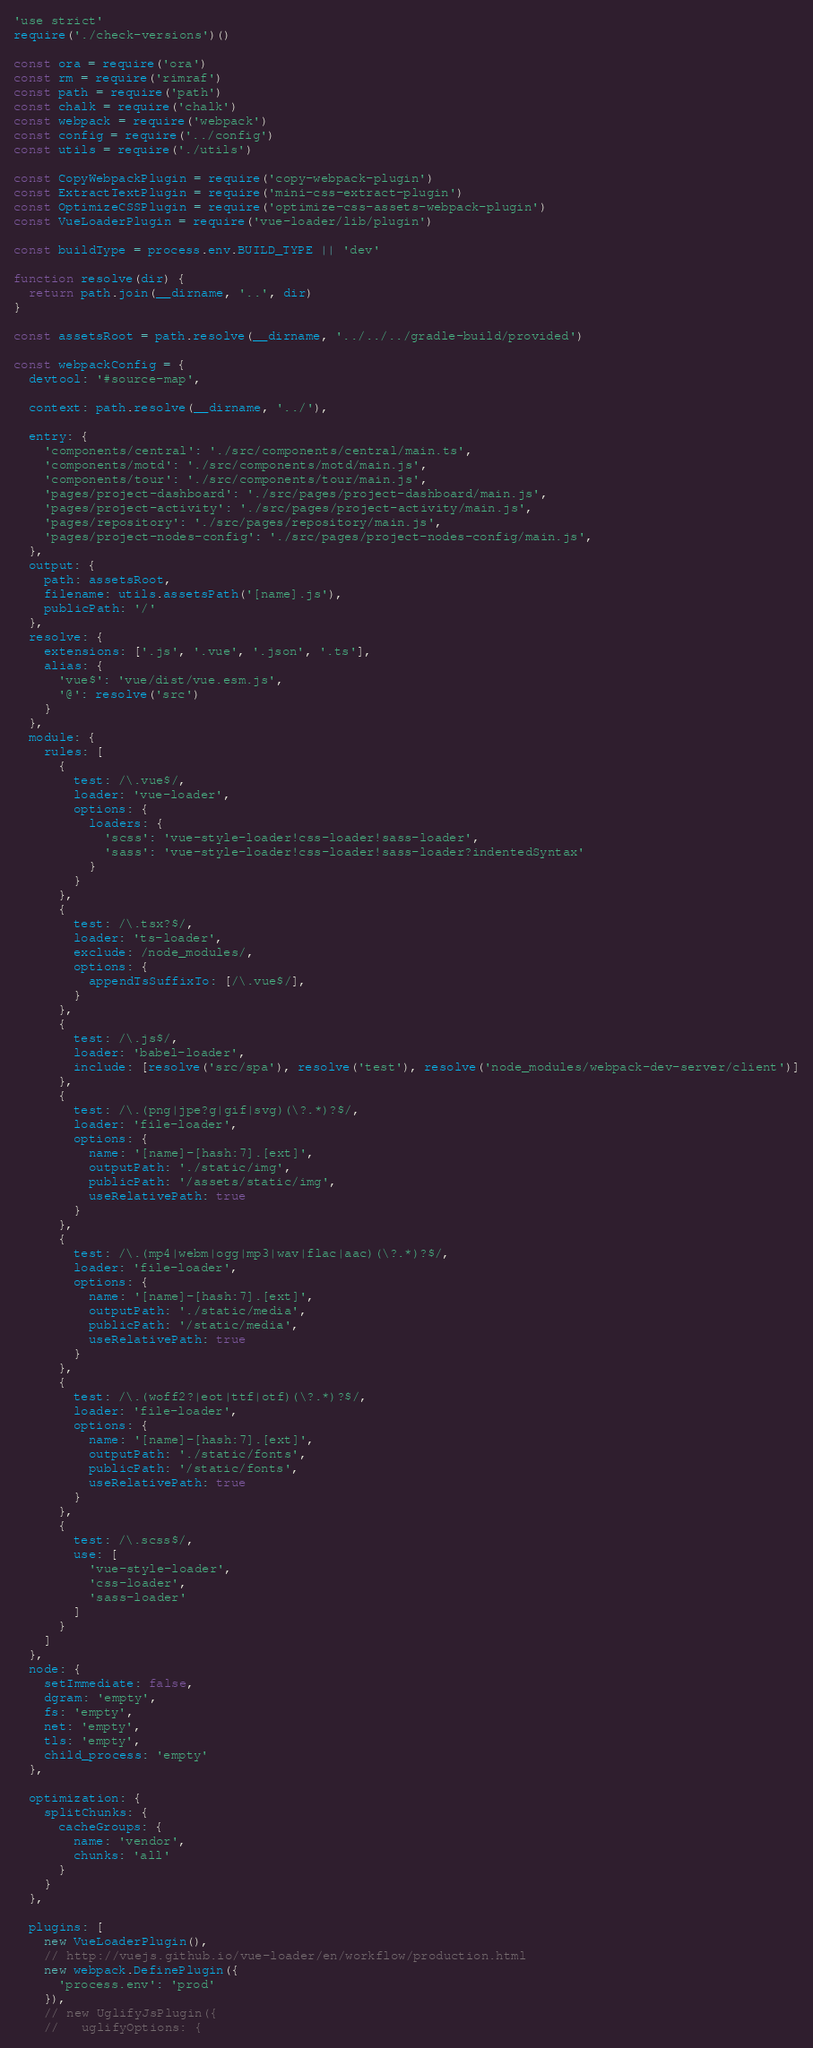<code> <loc_0><loc_0><loc_500><loc_500><_JavaScript_>'use strict'
require('./check-versions')()

const ora = require('ora')
const rm = require('rimraf')
const path = require('path')
const chalk = require('chalk')
const webpack = require('webpack')
const config = require('../config')
const utils = require('./utils')

const CopyWebpackPlugin = require('copy-webpack-plugin')
const ExtractTextPlugin = require('mini-css-extract-plugin')
const OptimizeCSSPlugin = require('optimize-css-assets-webpack-plugin')
const VueLoaderPlugin = require('vue-loader/lib/plugin')

const buildType = process.env.BUILD_TYPE || 'dev'

function resolve(dir) {
  return path.join(__dirname, '..', dir)
}

const assetsRoot = path.resolve(__dirname, '../../../gradle-build/provided')

const webpackConfig = {
  devtool: '#source-map',

  context: path.resolve(__dirname, '../'),

  entry: {
    'components/central': './src/components/central/main.ts',
    'components/motd': './src/components/motd/main.js',
    'components/tour': './src/components/tour/main.js',
    'pages/project-dashboard': './src/pages/project-dashboard/main.js',
    'pages/project-activity': './src/pages/project-activity/main.js',
    'pages/repository': './src/pages/repository/main.js',
    'pages/project-nodes-config': './src/pages/project-nodes-config/main.js',
  },
  output: {
    path: assetsRoot,
    filename: utils.assetsPath('[name].js'),
    publicPath: '/'
  },
  resolve: {
    extensions: ['.js', '.vue', '.json', '.ts'],
    alias: {
      'vue$': 'vue/dist/vue.esm.js',
      '@': resolve('src')
    }
  },
  module: {
    rules: [
      {
        test: /\.vue$/,
        loader: 'vue-loader',
        options: {
          loaders: {
            'scss': 'vue-style-loader!css-loader!sass-loader',
            'sass': 'vue-style-loader!css-loader!sass-loader?indentedSyntax'
          }
        }
      },
      {
        test: /\.tsx?$/,
        loader: 'ts-loader',
        exclude: /node_modules/,
        options: {
          appendTsSuffixTo: [/\.vue$/],
        }
      },
      {
        test: /\.js$/,
        loader: 'babel-loader',
        include: [resolve('src/spa'), resolve('test'), resolve('node_modules/webpack-dev-server/client')]
      },
      {
        test: /\.(png|jpe?g|gif|svg)(\?.*)?$/,
        loader: 'file-loader',
        options: {
          name: '[name]-[hash:7].[ext]',
          outputPath: './static/img',
          publicPath: '/assets/static/img',
          useRelativePath: true
        }
      },
      {
        test: /\.(mp4|webm|ogg|mp3|wav|flac|aac)(\?.*)?$/,
        loader: 'file-loader',
        options: {
          name: '[name]-[hash:7].[ext]',
          outputPath: './static/media',
          publicPath: '/static/media',
          useRelativePath: true
        }
      },
      {
        test: /\.(woff2?|eot|ttf|otf)(\?.*)?$/,
        loader: 'file-loader',
        options: {
          name: '[name]-[hash:7].[ext]',
          outputPath: './static/fonts',
          publicPath: '/static/fonts',
          useRelativePath: true
        }
      },
      {
        test: /\.scss$/,
        use: [
          'vue-style-loader',
          'css-loader',
          'sass-loader'
        ]
      }
    ]
  },
  node: {
    setImmediate: false,
    dgram: 'empty',
    fs: 'empty',
    net: 'empty',
    tls: 'empty',
    child_process: 'empty'
  },

  optimization: {
    splitChunks: {
      cacheGroups: {
        name: 'vendor',
        chunks: 'all'
      }
    }
  },

  plugins: [
    new VueLoaderPlugin(),
    // http://vuejs.github.io/vue-loader/en/workflow/production.html
    new webpack.DefinePlugin({
      'process.env': 'prod'
    }),
    // new UglifyJsPlugin({
    //   uglifyOptions: {</code> 